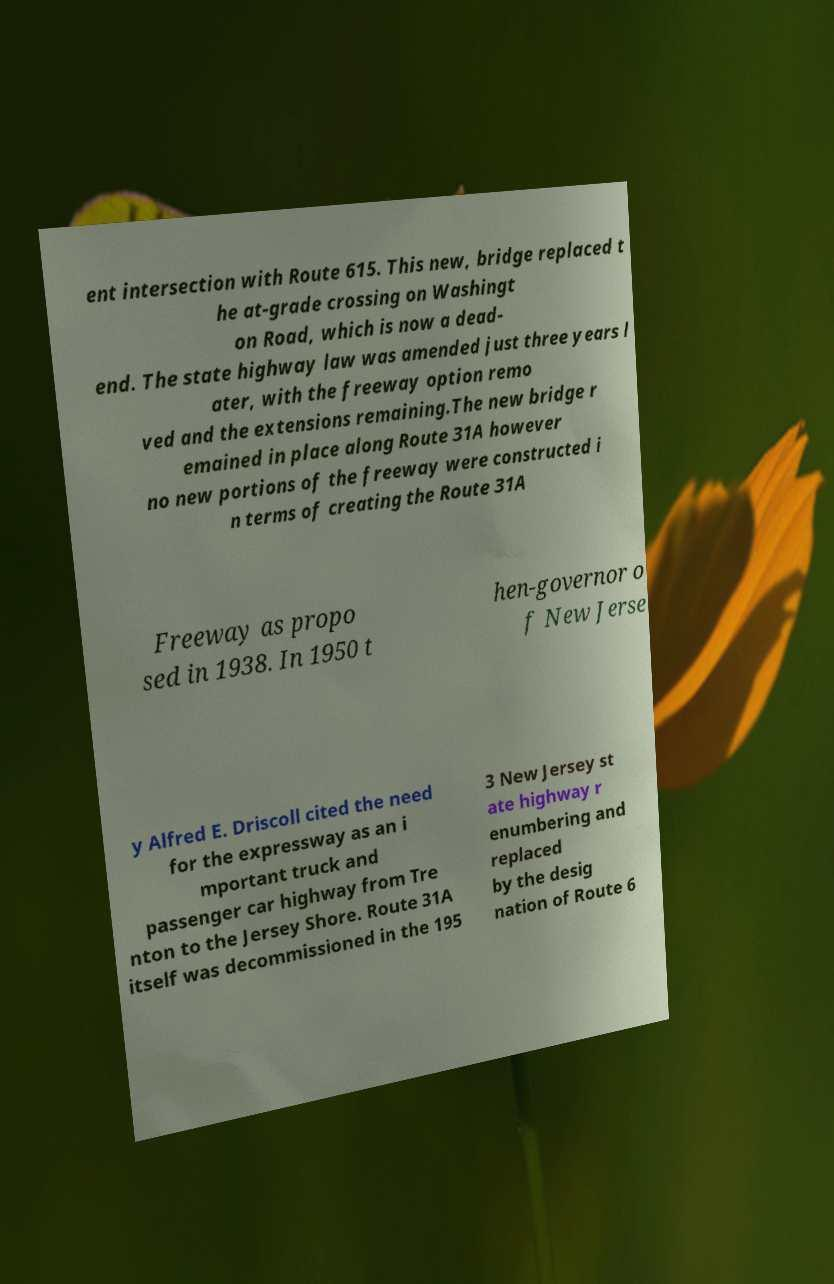What messages or text are displayed in this image? I need them in a readable, typed format. ent intersection with Route 615. This new, bridge replaced t he at-grade crossing on Washingt on Road, which is now a dead- end. The state highway law was amended just three years l ater, with the freeway option remo ved and the extensions remaining.The new bridge r emained in place along Route 31A however no new portions of the freeway were constructed i n terms of creating the Route 31A Freeway as propo sed in 1938. In 1950 t hen-governor o f New Jerse y Alfred E. Driscoll cited the need for the expressway as an i mportant truck and passenger car highway from Tre nton to the Jersey Shore. Route 31A itself was decommissioned in the 195 3 New Jersey st ate highway r enumbering and replaced by the desig nation of Route 6 